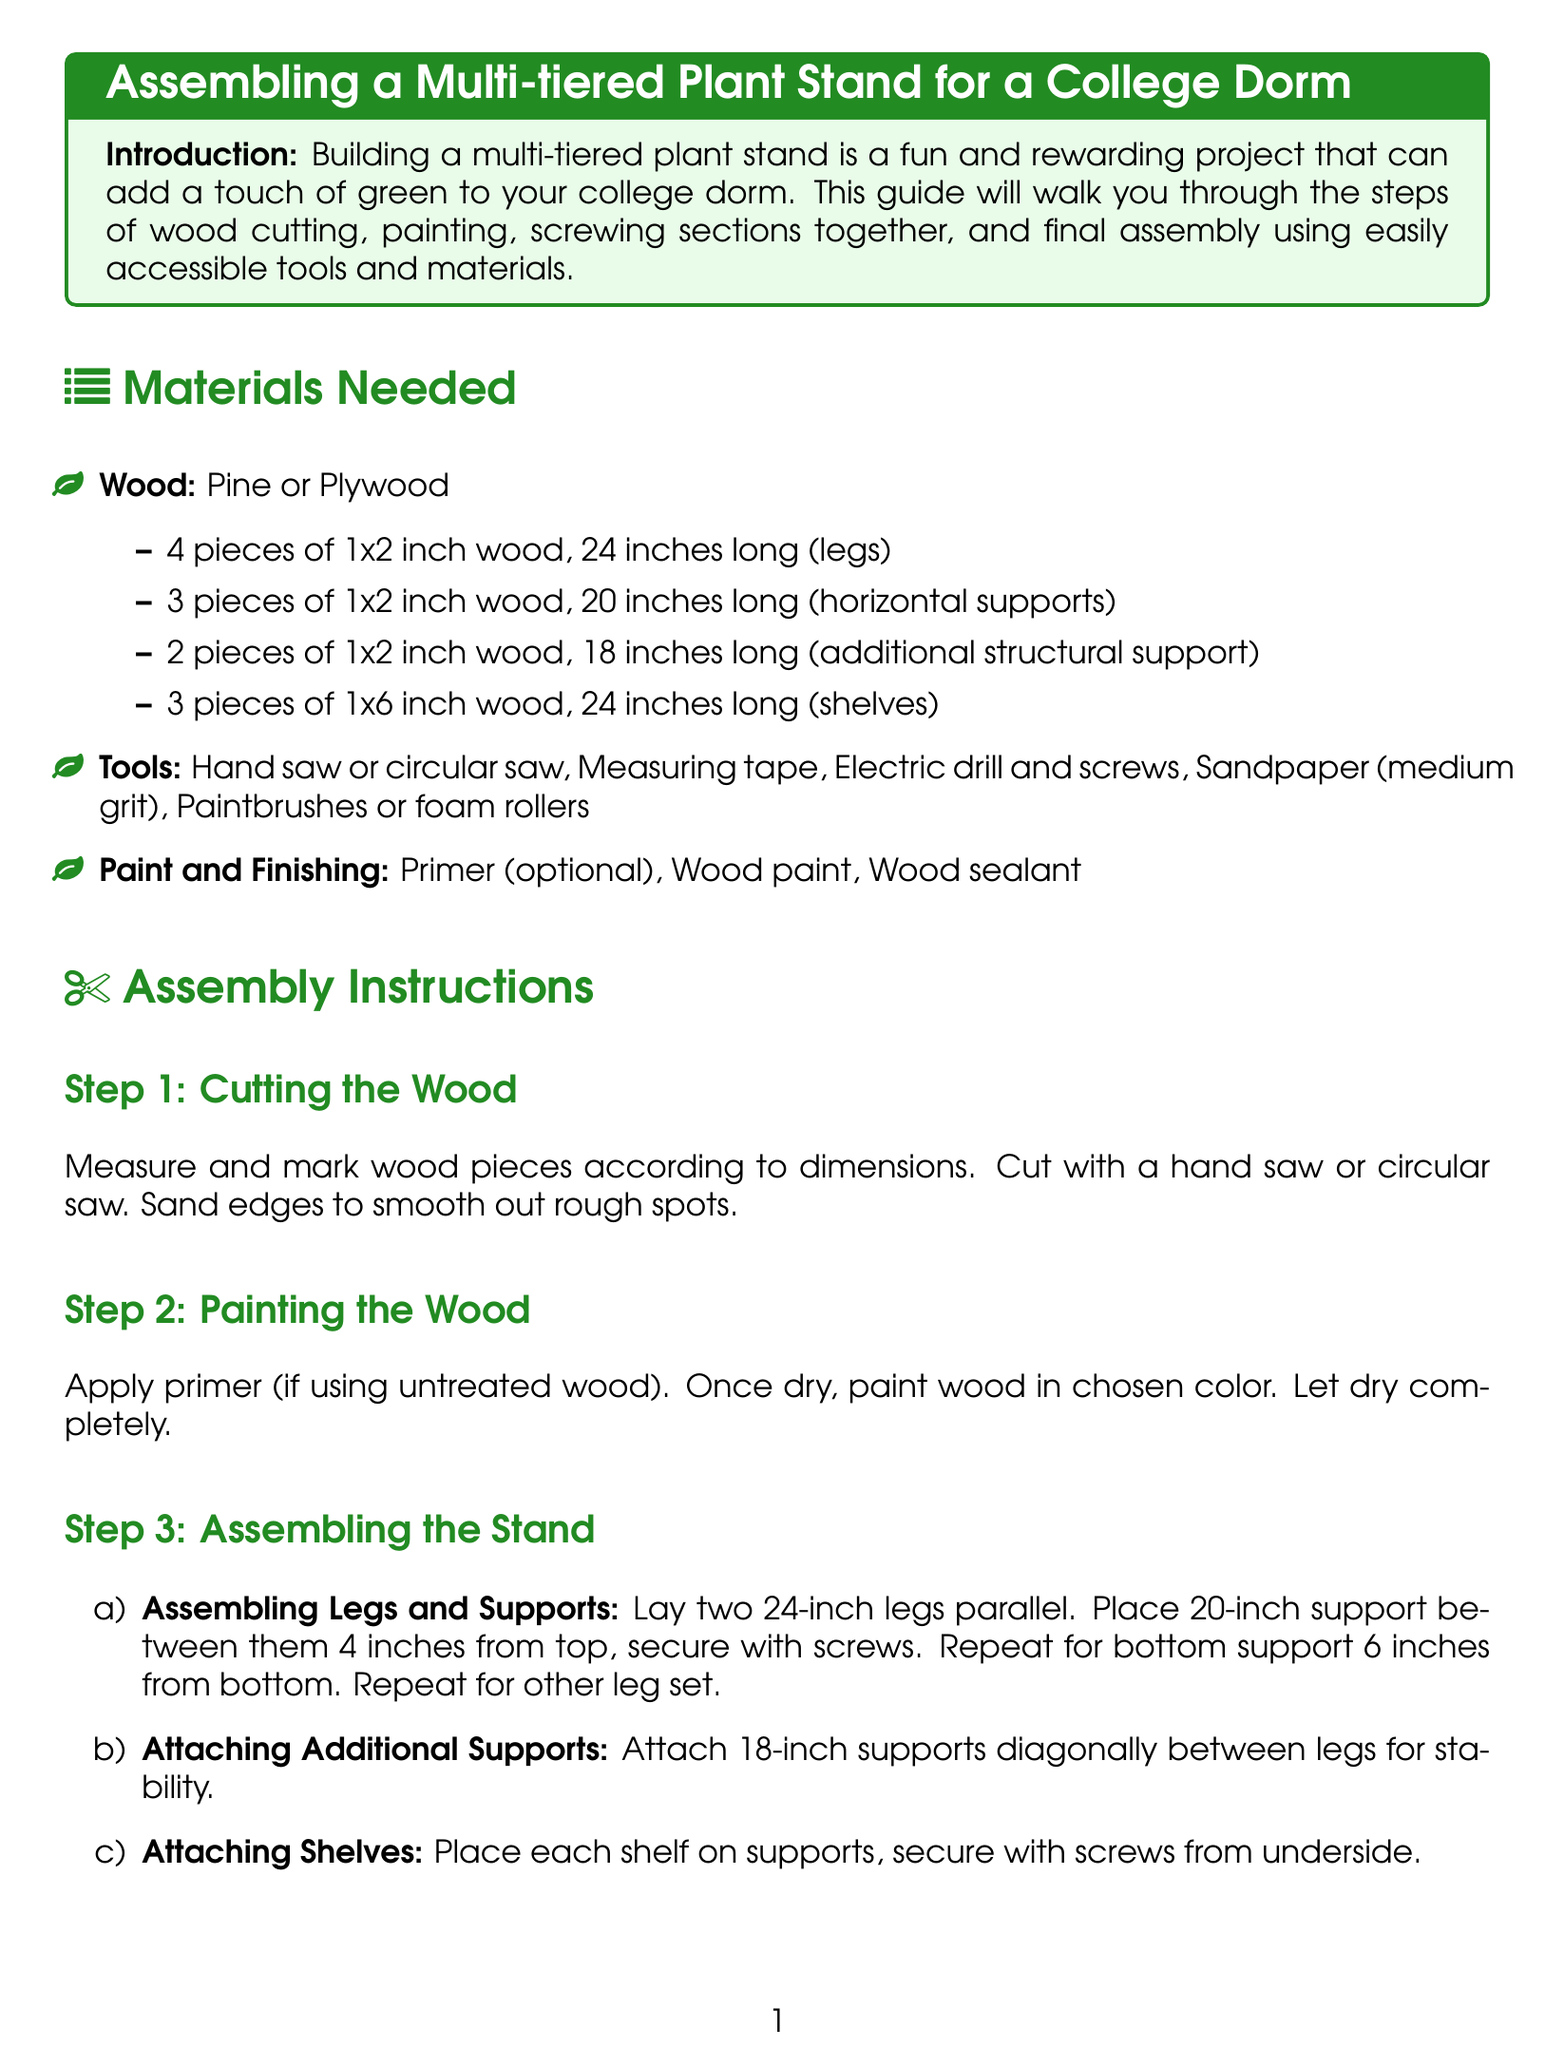what type of wood is recommended? The document suggests using either pine or plywood for the plant stand.
Answer: Pine or plywood how many pieces of 1x2 inch wood are required for the legs? The instructions specify 4 pieces of 1x2 inch wood that are 24 inches long for the legs.
Answer: 4 pieces what is the length of the shelves? The shelves need to be 24 inches long each according to the document.
Answer: 24 inches how far from the top should the first support be placed? The first 20-inch support should be placed 4 inches from the top of the legs.
Answer: 4 inches what is the purpose of applying wood sealant? The wood sealant is applied for protection of the plant stand after assembly.
Answer: Protection how many diagonal supports are added for stability? Two 18-inch supports are attached diagonally between the legs for added stability.
Answer: 2 what tool is recommended for cutting the wood? The document mentions using a hand saw or a circular saw for cutting the wood.
Answer: Hand saw or circular saw which painting technique is suggested? The instructions recommend using a paintbrush or foam rollers for applying paint.
Answer: Paintbrushes or foam rollers 